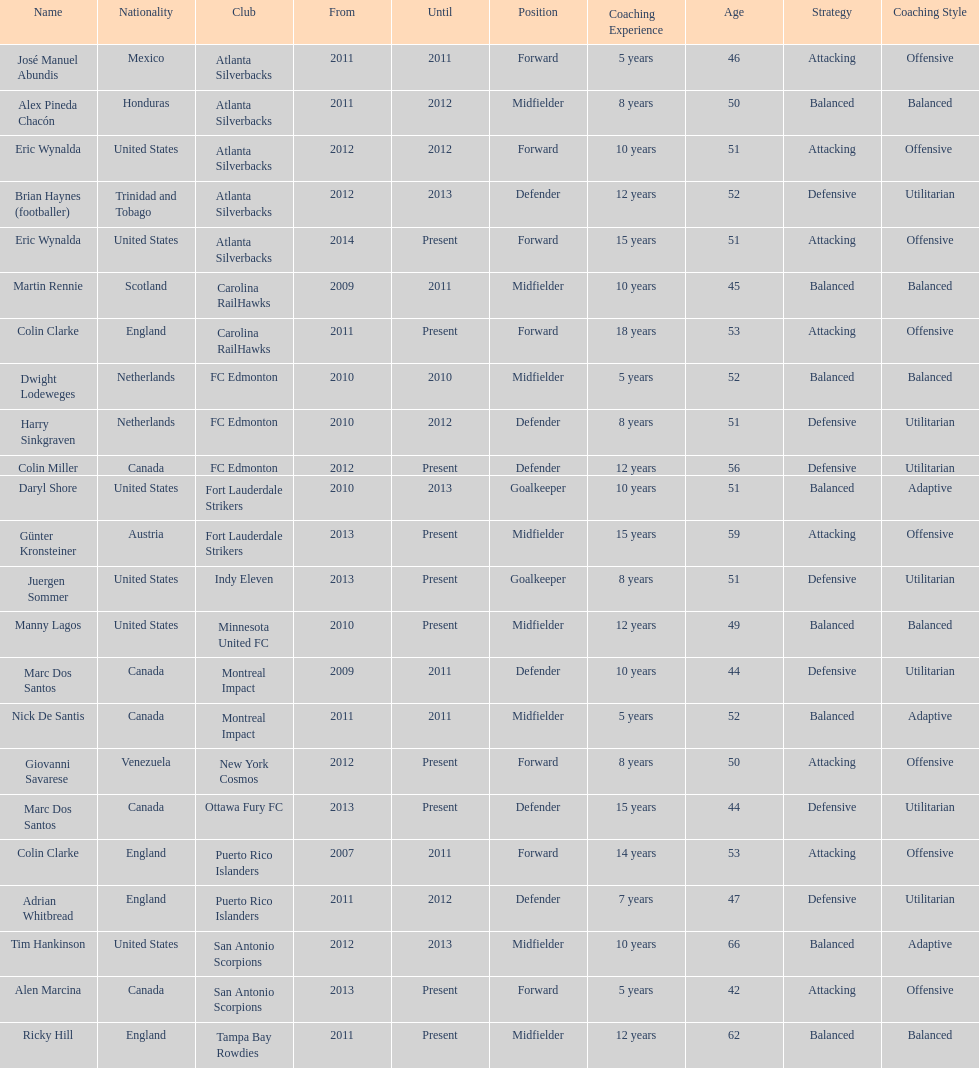Parse the table in full. {'header': ['Name', 'Nationality', 'Club', 'From', 'Until', 'Position', 'Coaching Experience', 'Age', 'Strategy', 'Coaching Style'], 'rows': [['José Manuel Abundis', 'Mexico', 'Atlanta Silverbacks', '2011', '2011', 'Forward', '5 years', '46', 'Attacking', 'Offensive'], ['Alex Pineda Chacón', 'Honduras', 'Atlanta Silverbacks', '2011', '2012', 'Midfielder', '8 years', '50', 'Balanced', 'Balanced'], ['Eric Wynalda', 'United States', 'Atlanta Silverbacks', '2012', '2012', 'Forward', '10 years', '51', 'Attacking', 'Offensive '], ['Brian Haynes (footballer)', 'Trinidad and Tobago', 'Atlanta Silverbacks', '2012', '2013', 'Defender', '12 years', '52', 'Defensive', 'Utilitarian'], ['Eric Wynalda', 'United States', 'Atlanta Silverbacks', '2014', 'Present', 'Forward', '15 years', '51', 'Attacking', 'Offensive'], ['Martin Rennie', 'Scotland', 'Carolina RailHawks', '2009', '2011', 'Midfielder', '10 years', '45', 'Balanced', 'Balanced'], ['Colin Clarke', 'England', 'Carolina RailHawks', '2011', 'Present', 'Forward', '18 years', '53', 'Attacking', 'Offensive'], ['Dwight Lodeweges', 'Netherlands', 'FC Edmonton', '2010', '2010', 'Midfielder', '5 years', '52', 'Balanced', 'Balanced'], ['Harry Sinkgraven', 'Netherlands', 'FC Edmonton', '2010', '2012', 'Defender', '8 years', '51', 'Defensive', 'Utilitarian'], ['Colin Miller', 'Canada', 'FC Edmonton', '2012', 'Present', 'Defender', '12 years', '56', 'Defensive', 'Utilitarian'], ['Daryl Shore', 'United States', 'Fort Lauderdale Strikers', '2010', '2013', 'Goalkeeper', '10 years', '51', 'Balanced', 'Adaptive'], ['Günter Kronsteiner', 'Austria', 'Fort Lauderdale Strikers', '2013', 'Present', 'Midfielder', '15 years', '59', 'Attacking', 'Offensive'], ['Juergen Sommer', 'United States', 'Indy Eleven', '2013', 'Present', 'Goalkeeper', '8 years', '51', 'Defensive', 'Utilitarian'], ['Manny Lagos', 'United States', 'Minnesota United FC', '2010', 'Present', 'Midfielder', '12 years', '49', 'Balanced', 'Balanced'], ['Marc Dos Santos', 'Canada', 'Montreal Impact', '2009', '2011', 'Defender', '10 years', '44', 'Defensive', 'Utilitarian'], ['Nick De Santis', 'Canada', 'Montreal Impact', '2011', '2011', 'Midfielder', '5 years', '52', 'Balanced', 'Adaptive'], ['Giovanni Savarese', 'Venezuela', 'New York Cosmos', '2012', 'Present', 'Forward', '8 years', '50', 'Attacking', 'Offensive'], ['Marc Dos Santos', 'Canada', 'Ottawa Fury FC', '2013', 'Present', 'Defender', '15 years', '44', 'Defensive', 'Utilitarian'], ['Colin Clarke', 'England', 'Puerto Rico Islanders', '2007', '2011', 'Forward', '14 years', '53', 'Attacking', 'Offensive'], ['Adrian Whitbread', 'England', 'Puerto Rico Islanders', '2011', '2012', 'Defender', '7 years', '47', 'Defensive', 'Utilitarian'], ['Tim Hankinson', 'United States', 'San Antonio Scorpions', '2012', '2013', 'Midfielder', '10 years', '66', 'Balanced', 'Adaptive'], ['Alen Marcina', 'Canada', 'San Antonio Scorpions', '2013', 'Present', 'Forward', '5 years', '42', 'Attacking', 'Offensive'], ['Ricky Hill', 'England', 'Tampa Bay Rowdies', '2011', 'Present', 'Midfielder', '12 years', '62', 'Balanced', 'Balanced']]} What name is listed at the top? José Manuel Abundis. 